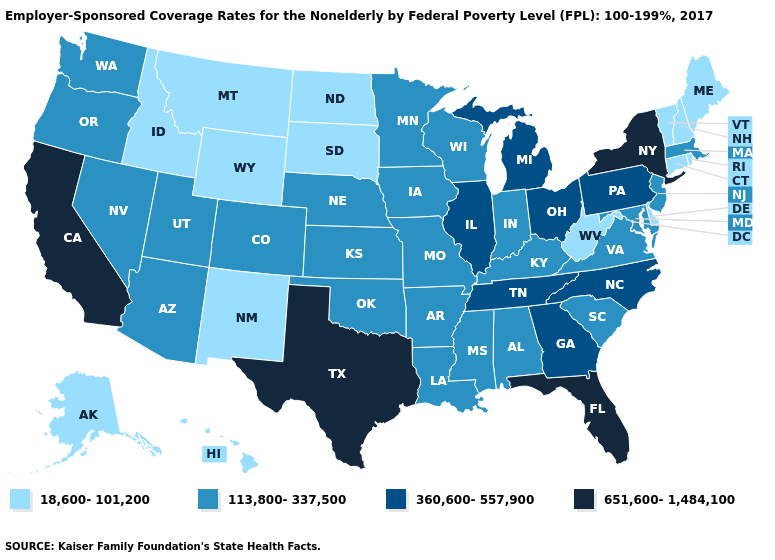Name the states that have a value in the range 360,600-557,900?
Short answer required. Georgia, Illinois, Michigan, North Carolina, Ohio, Pennsylvania, Tennessee. Does Michigan have a lower value than Vermont?
Be succinct. No. Among the states that border Vermont , does Massachusetts have the lowest value?
Give a very brief answer. No. Does New Jersey have a higher value than New Hampshire?
Keep it brief. Yes. What is the value of Georgia?
Short answer required. 360,600-557,900. Name the states that have a value in the range 18,600-101,200?
Quick response, please. Alaska, Connecticut, Delaware, Hawaii, Idaho, Maine, Montana, New Hampshire, New Mexico, North Dakota, Rhode Island, South Dakota, Vermont, West Virginia, Wyoming. Does South Dakota have the lowest value in the USA?
Quick response, please. Yes. What is the highest value in the USA?
Be succinct. 651,600-1,484,100. Which states have the lowest value in the West?
Quick response, please. Alaska, Hawaii, Idaho, Montana, New Mexico, Wyoming. What is the lowest value in states that border Kentucky?
Keep it brief. 18,600-101,200. What is the lowest value in the Northeast?
Answer briefly. 18,600-101,200. Does New Mexico have the same value as Utah?
Give a very brief answer. No. Name the states that have a value in the range 360,600-557,900?
Give a very brief answer. Georgia, Illinois, Michigan, North Carolina, Ohio, Pennsylvania, Tennessee. Which states have the lowest value in the USA?
Write a very short answer. Alaska, Connecticut, Delaware, Hawaii, Idaho, Maine, Montana, New Hampshire, New Mexico, North Dakota, Rhode Island, South Dakota, Vermont, West Virginia, Wyoming. 